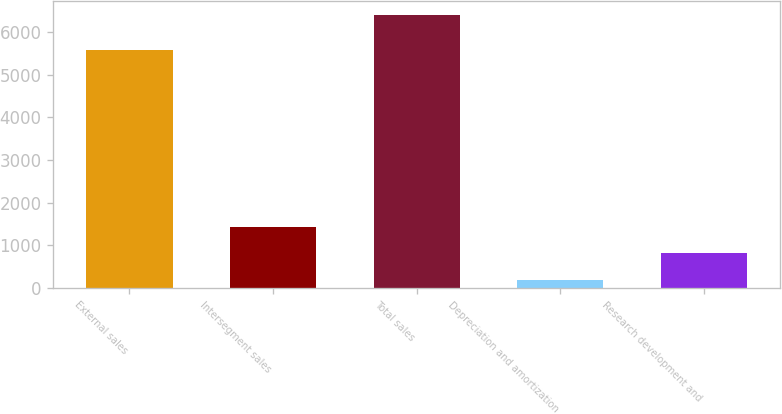Convert chart. <chart><loc_0><loc_0><loc_500><loc_500><bar_chart><fcel>External sales<fcel>Intersegment sales<fcel>Total sales<fcel>Depreciation and amortization<fcel>Research development and<nl><fcel>5582<fcel>1429<fcel>6405<fcel>185<fcel>807<nl></chart> 